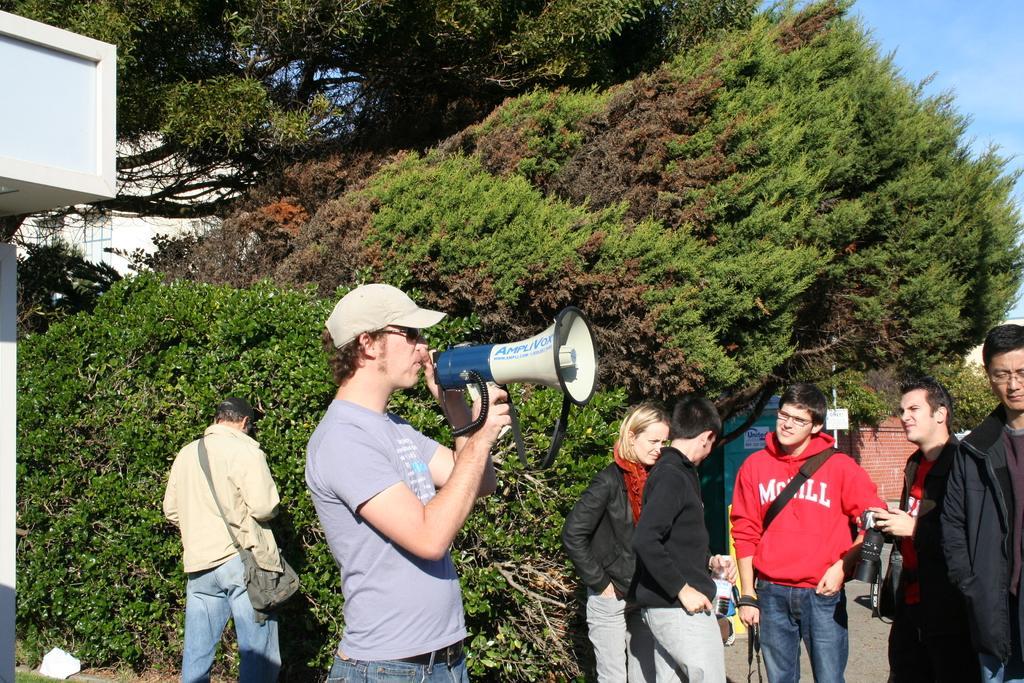Describe this image in one or two sentences. This picture describes about group of people, in the middle of the image we can see a man, he wore a cap and he is holding a megaphone, in the background we can see few trees, buildings and a pole. 